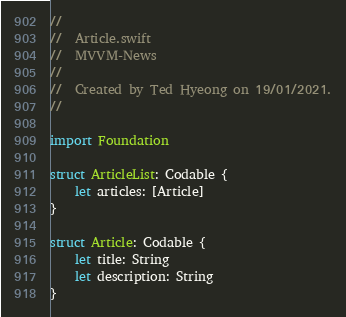Convert code to text. <code><loc_0><loc_0><loc_500><loc_500><_Swift_>//
//  Article.swift
//  MVVM-News
//
//  Created by Ted Hyeong on 19/01/2021.
//

import Foundation

struct ArticleList: Codable {
    let articles: [Article]
}

struct Article: Codable {
    let title: String
    let description: String
}
</code> 